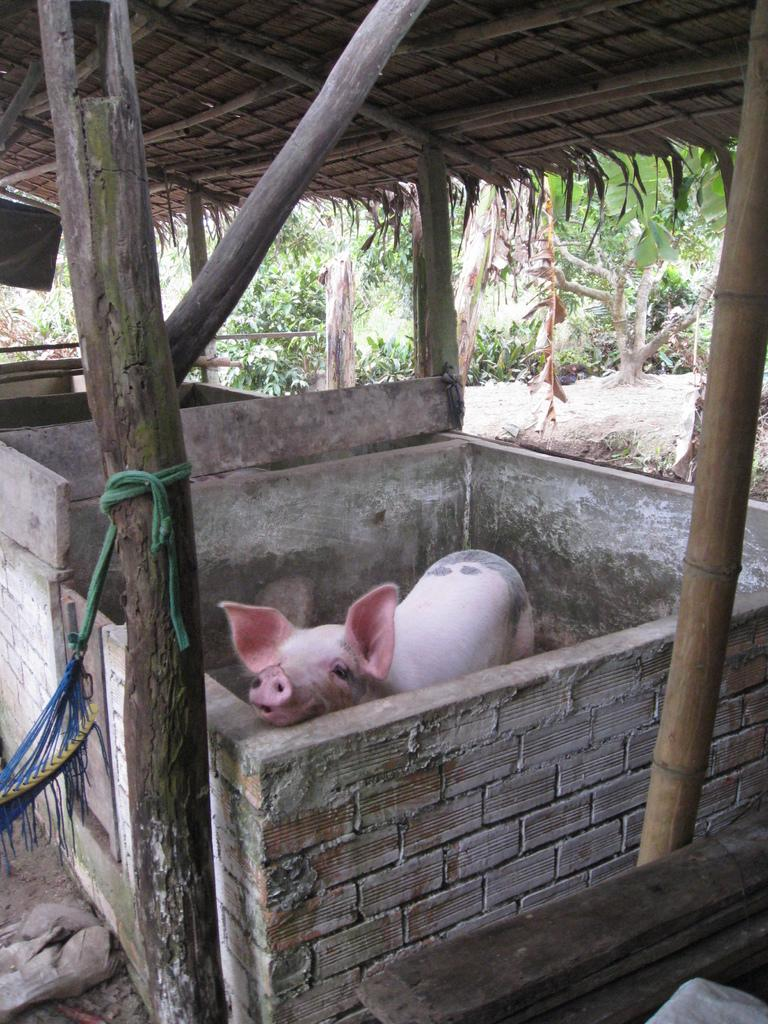What animal is present in the image? There is a red color pig in the image. What is the pig's immediate environment like? The pig is surrounded by a wall. What material is used for the roof in the image? The roof in the image is made up of wood. What type of work is the pig doing in the image? The image does not depict the pig doing any work; it simply shows the pig surrounded by a wall. 